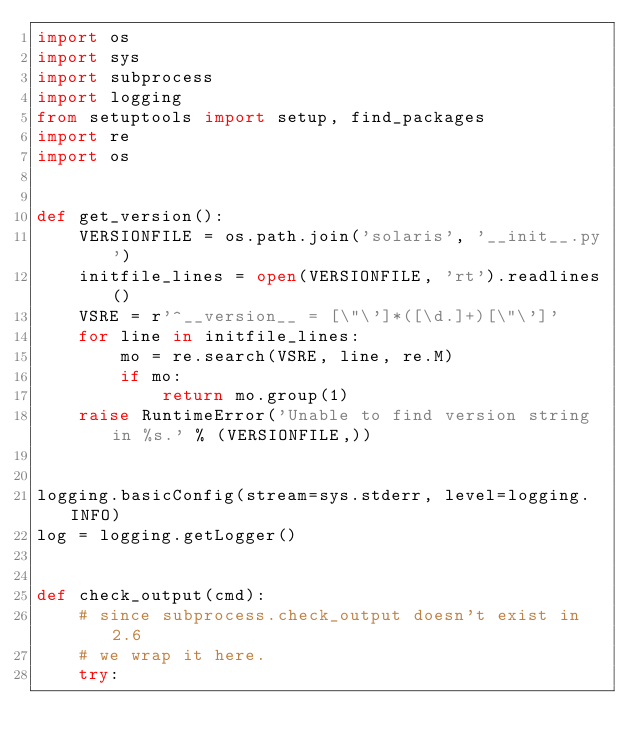Convert code to text. <code><loc_0><loc_0><loc_500><loc_500><_Python_>import os
import sys
import subprocess
import logging
from setuptools import setup, find_packages
import re
import os


def get_version():
    VERSIONFILE = os.path.join('solaris', '__init__.py')
    initfile_lines = open(VERSIONFILE, 'rt').readlines()
    VSRE = r'^__version__ = [\"\']*([\d.]+)[\"\']'
    for line in initfile_lines:
        mo = re.search(VSRE, line, re.M)
        if mo:
            return mo.group(1)
    raise RuntimeError('Unable to find version string in %s.' % (VERSIONFILE,))


logging.basicConfig(stream=sys.stderr, level=logging.INFO)
log = logging.getLogger()


def check_output(cmd):
    # since subprocess.check_output doesn't exist in 2.6
    # we wrap it here.
    try:</code> 